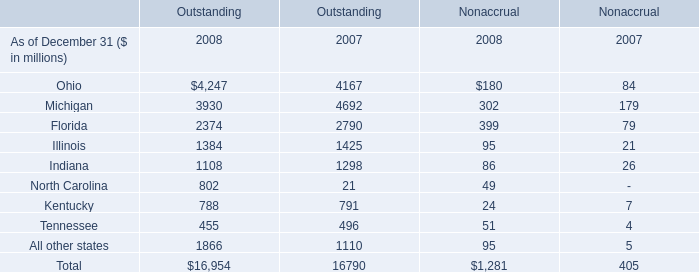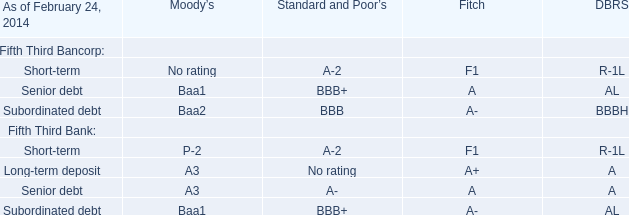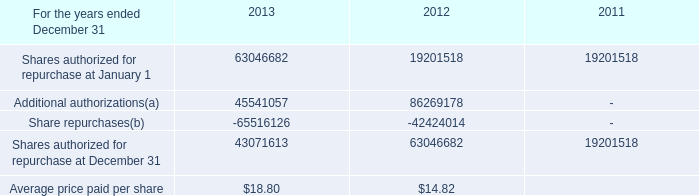What is the proportion of the Outstanding of Ohio to the Outstanding of Total in 2008? 
Computations: (4247 / 16954)
Answer: 0.2505. 